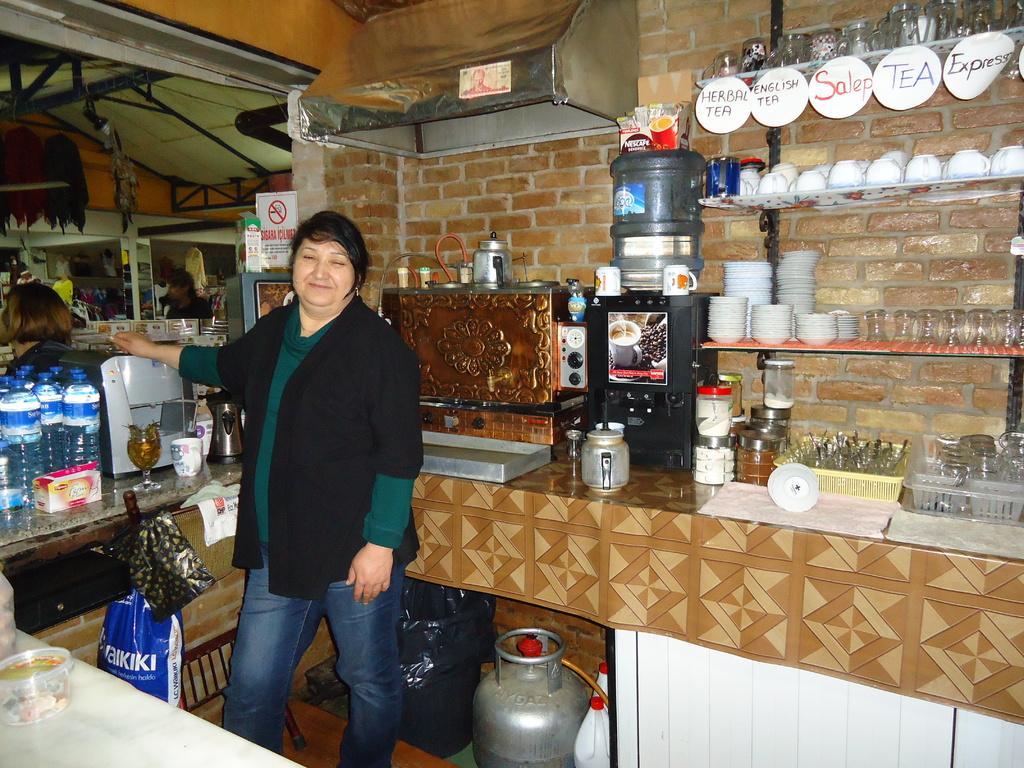Can you describe this image briefly? This is the woman standing and smiling. I can see cups, bowls, glasses and glass jars are placed in the rack. These are the papers hanging. This looks like a coffee machine. this is the water can. I can see a kettle, bottles, trays, napkins and few other things are placed on the cabin. This looks like a cylinder. I think this is the dustbin. These are the bags hanging. I can see the water bottles, wine glass, cup, kettle and few other things placed here. This looks like a chimney. I can see a person here. 